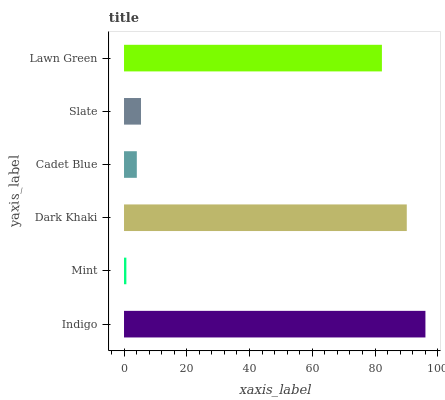Is Mint the minimum?
Answer yes or no. Yes. Is Indigo the maximum?
Answer yes or no. Yes. Is Dark Khaki the minimum?
Answer yes or no. No. Is Dark Khaki the maximum?
Answer yes or no. No. Is Dark Khaki greater than Mint?
Answer yes or no. Yes. Is Mint less than Dark Khaki?
Answer yes or no. Yes. Is Mint greater than Dark Khaki?
Answer yes or no. No. Is Dark Khaki less than Mint?
Answer yes or no. No. Is Lawn Green the high median?
Answer yes or no. Yes. Is Slate the low median?
Answer yes or no. Yes. Is Dark Khaki the high median?
Answer yes or no. No. Is Mint the low median?
Answer yes or no. No. 